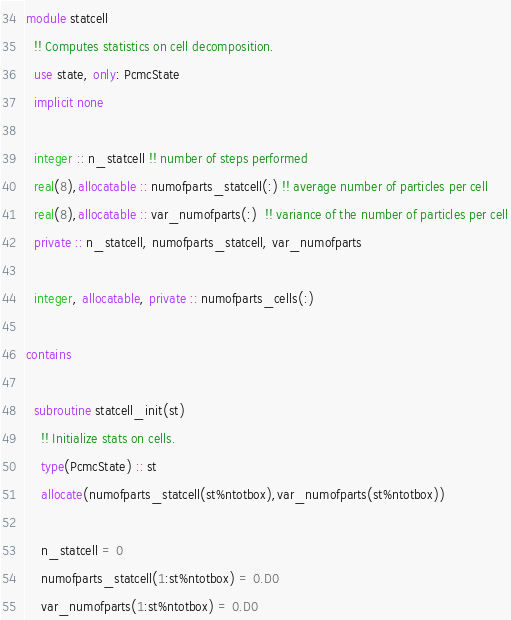<code> <loc_0><loc_0><loc_500><loc_500><_FORTRAN_>
module statcell
  !! Computes statistics on cell decomposition.
  use state, only: PcmcState
  implicit none

  integer :: n_statcell !! number of steps performed
  real(8),allocatable :: numofparts_statcell(:) !! average number of particles per cell
  real(8),allocatable :: var_numofparts(:)  !! variance of the number of particles per cell
  private :: n_statcell, numofparts_statcell, var_numofparts

  integer, allocatable, private :: numofparts_cells(:)
  
contains

  subroutine statcell_init(st)
    !! Initialize stats on cells.
    type(PcmcState) :: st
    allocate(numofparts_statcell(st%ntotbox),var_numofparts(st%ntotbox))

    n_statcell = 0
    numofparts_statcell(1:st%ntotbox) = 0.D0
    var_numofparts(1:st%ntotbox) = 0.D0</code> 